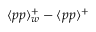<formula> <loc_0><loc_0><loc_500><loc_500>\langle p p \rangle _ { w } ^ { + } - \langle p p \rangle ^ { + }</formula> 